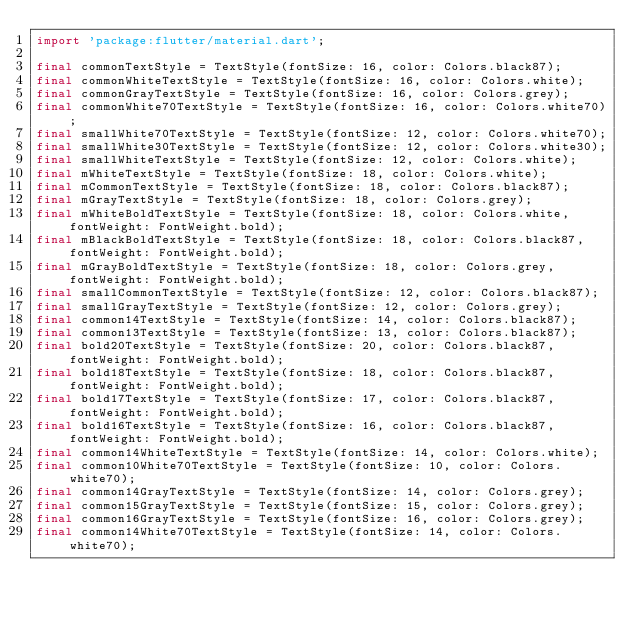<code> <loc_0><loc_0><loc_500><loc_500><_Dart_>import 'package:flutter/material.dart';

final commonTextStyle = TextStyle(fontSize: 16, color: Colors.black87);
final commonWhiteTextStyle = TextStyle(fontSize: 16, color: Colors.white);
final commonGrayTextStyle = TextStyle(fontSize: 16, color: Colors.grey);
final commonWhite70TextStyle = TextStyle(fontSize: 16, color: Colors.white70);
final smallWhite70TextStyle = TextStyle(fontSize: 12, color: Colors.white70);
final smallWhite30TextStyle = TextStyle(fontSize: 12, color: Colors.white30);
final smallWhiteTextStyle = TextStyle(fontSize: 12, color: Colors.white);
final mWhiteTextStyle = TextStyle(fontSize: 18, color: Colors.white);
final mCommonTextStyle = TextStyle(fontSize: 18, color: Colors.black87);
final mGrayTextStyle = TextStyle(fontSize: 18, color: Colors.grey);
final mWhiteBoldTextStyle = TextStyle(fontSize: 18, color: Colors.white, fontWeight: FontWeight.bold);
final mBlackBoldTextStyle = TextStyle(fontSize: 18, color: Colors.black87, fontWeight: FontWeight.bold);
final mGrayBoldTextStyle = TextStyle(fontSize: 18, color: Colors.grey, fontWeight: FontWeight.bold);
final smallCommonTextStyle = TextStyle(fontSize: 12, color: Colors.black87);
final smallGrayTextStyle = TextStyle(fontSize: 12, color: Colors.grey);
final common14TextStyle = TextStyle(fontSize: 14, color: Colors.black87);
final common13TextStyle = TextStyle(fontSize: 13, color: Colors.black87);
final bold20TextStyle = TextStyle(fontSize: 20, color: Colors.black87, fontWeight: FontWeight.bold);
final bold18TextStyle = TextStyle(fontSize: 18, color: Colors.black87, fontWeight: FontWeight.bold);
final bold17TextStyle = TextStyle(fontSize: 17, color: Colors.black87, fontWeight: FontWeight.bold);
final bold16TextStyle = TextStyle(fontSize: 16, color: Colors.black87, fontWeight: FontWeight.bold);
final common14WhiteTextStyle = TextStyle(fontSize: 14, color: Colors.white);
final common10White70TextStyle = TextStyle(fontSize: 10, color: Colors.white70);
final common14GrayTextStyle = TextStyle(fontSize: 14, color: Colors.grey);
final common15GrayTextStyle = TextStyle(fontSize: 15, color: Colors.grey);
final common16GrayTextStyle = TextStyle(fontSize: 16, color: Colors.grey);
final common14White70TextStyle = TextStyle(fontSize: 14, color: Colors.white70);</code> 